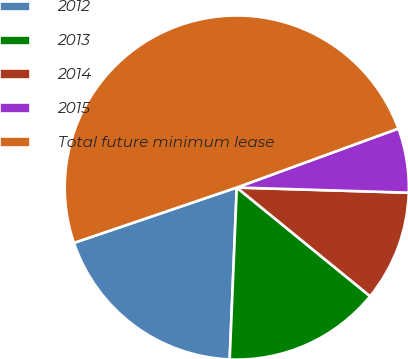<chart> <loc_0><loc_0><loc_500><loc_500><pie_chart><fcel>2012<fcel>2013<fcel>2014<fcel>2015<fcel>Total future minimum lease<nl><fcel>19.13%<fcel>14.77%<fcel>10.41%<fcel>6.05%<fcel>49.65%<nl></chart> 